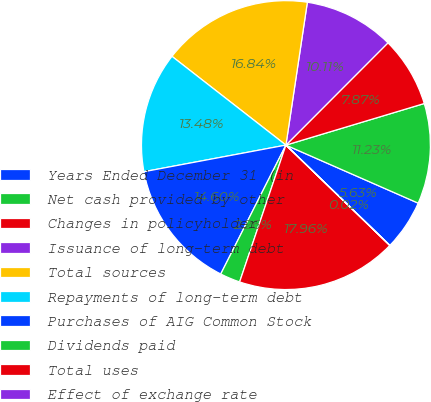Convert chart to OTSL. <chart><loc_0><loc_0><loc_500><loc_500><pie_chart><fcel>Years Ended December 31 (in<fcel>Net cash provided by other<fcel>Changes in policyholder<fcel>Issuance of long-term debt<fcel>Total sources<fcel>Repayments of long-term debt<fcel>Purchases of AIG Common Stock<fcel>Dividends paid<fcel>Total uses<fcel>Effect of exchange rate<nl><fcel>5.63%<fcel>11.23%<fcel>7.87%<fcel>10.11%<fcel>16.84%<fcel>13.48%<fcel>14.6%<fcel>2.26%<fcel>17.96%<fcel>0.02%<nl></chart> 